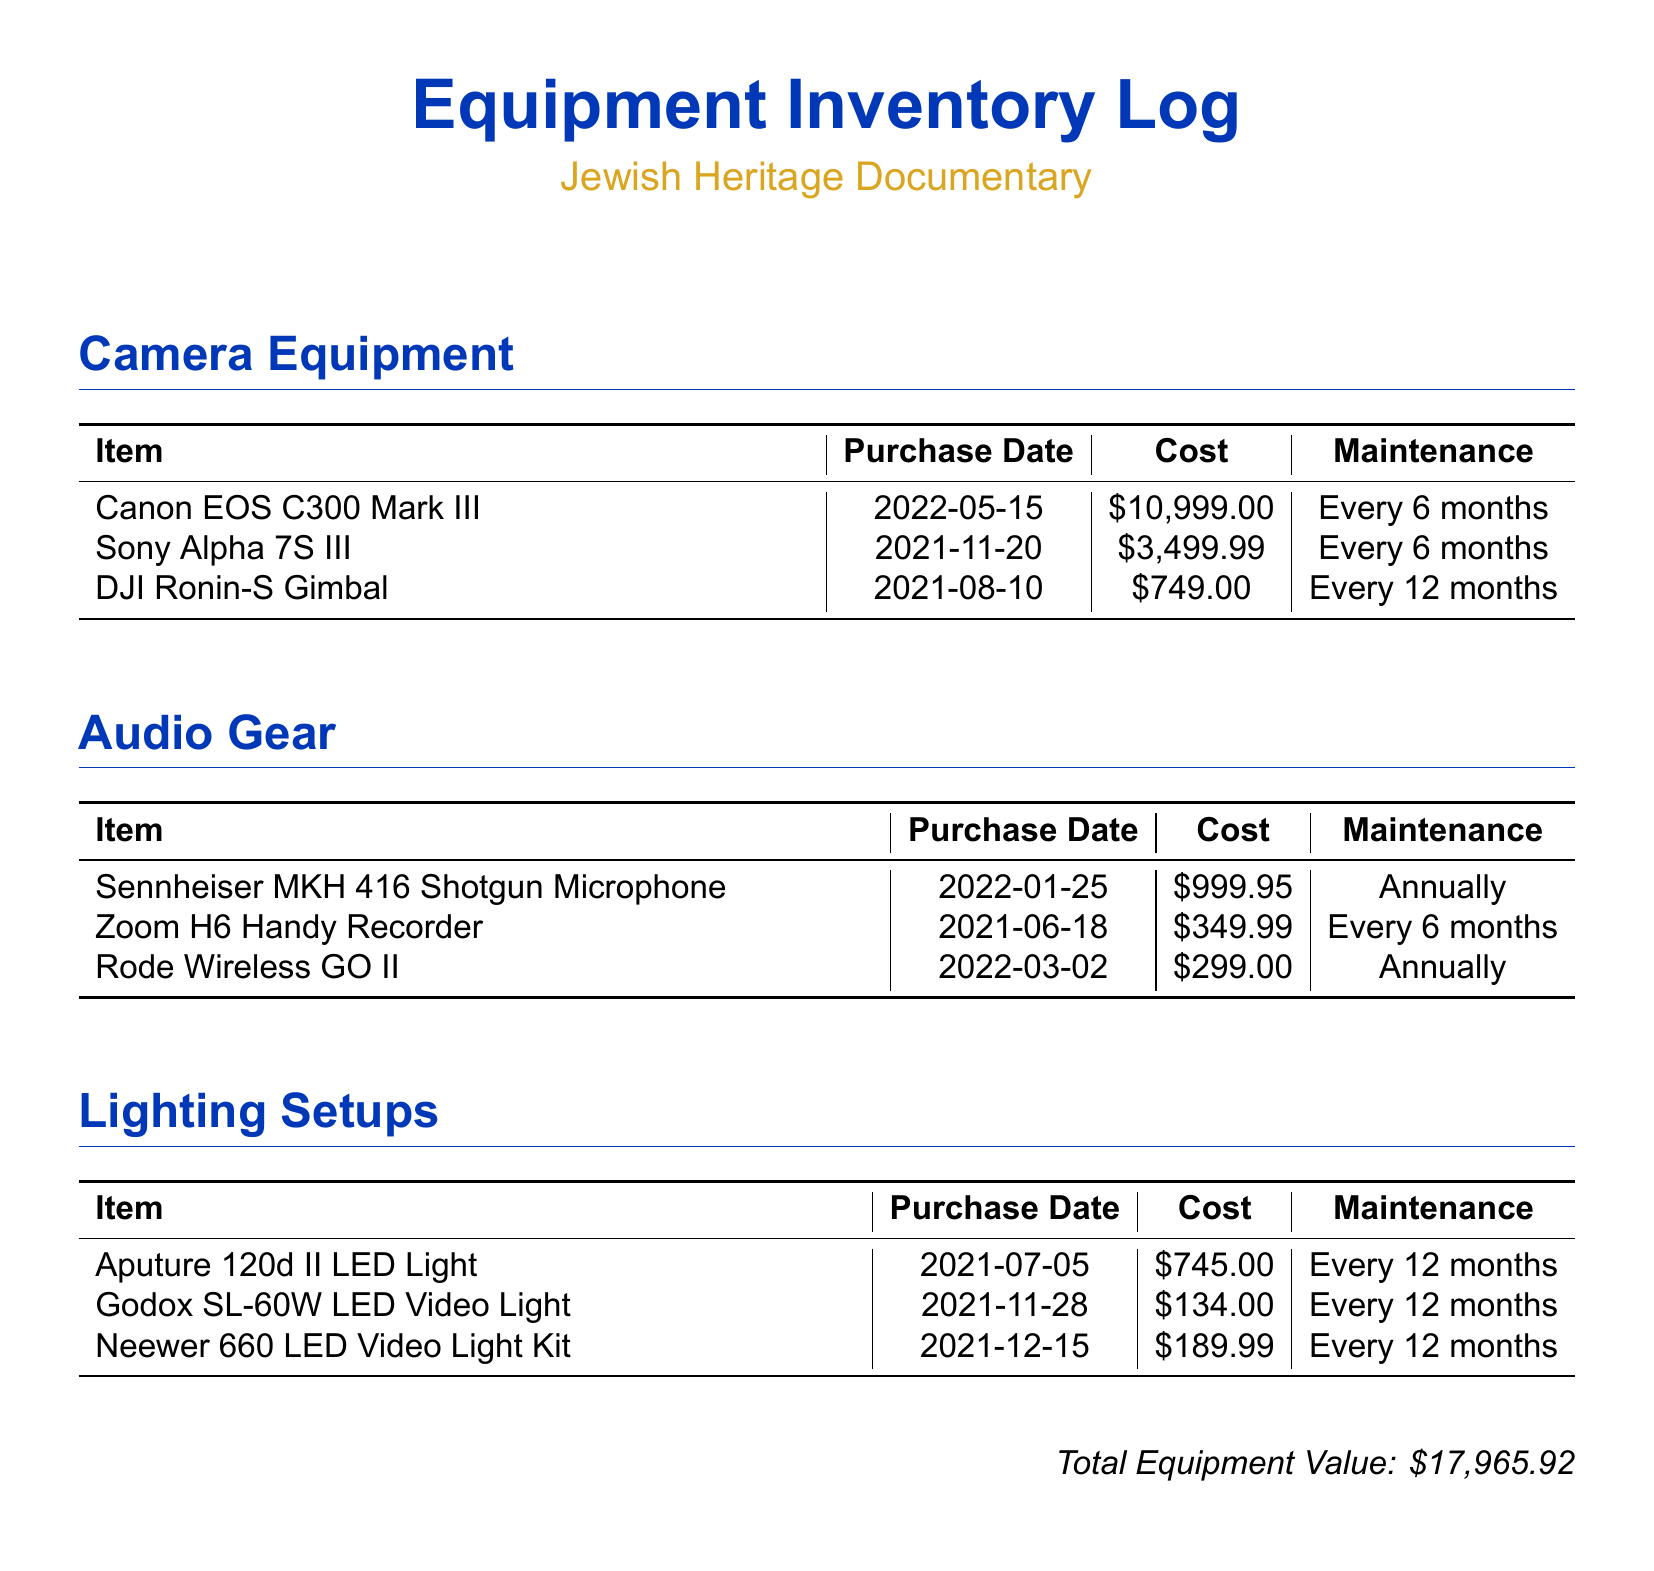What is the total equipment value? The total equipment value is explicitly stated at the bottom of the document.
Answer: $17,965.92 When was the Canon EOS C300 Mark III purchased? The purchase date for the Canon EOS C300 Mark III is listed in the camera equipment section.
Answer: 2022-05-15 What is the maintenance schedule for the Sennheiser MKH 416 Shotgun Microphone? The maintenance frequency for the Sennheiser MKH 416 is mentioned in the audio gear section.
Answer: Annually Which lighting item was purchased on 2021-11-28? The purchase date allows us to identify the specific lighting item, which is listed in the lighting setups section.
Answer: Godox SL-60W LED Video Light How much did the Rode Wireless GO II cost? The cost of the Rode Wireless GO II is specifically detailed in the audio gear section of the document.
Answer: $299.00 What proportion of the total equipment value does the Canon EOS C300 Mark III represent? This requires comparing the cost of the Canon EOS C300 Mark III with the total equipment value provided later in the document.
Answer: 61.24% How many items are listed in the Camera Equipment section? This is determined by counting the entries in the camera equipment section.
Answer: 3 What is the average cost of lighting setups? The average cost can be calculated by dividing the sum of all lighting costs by the number of lighting items listed.
Answer: $356.66 